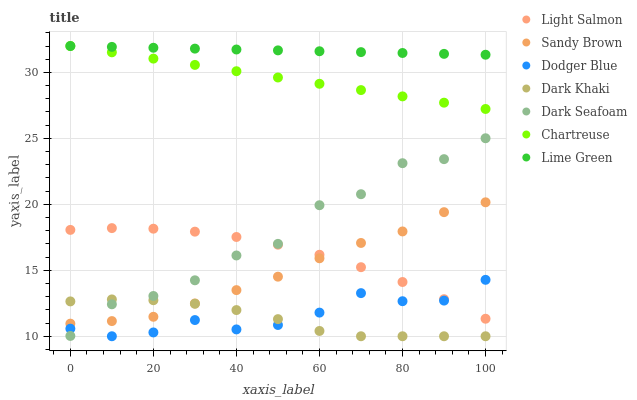Does Dark Khaki have the minimum area under the curve?
Answer yes or no. Yes. Does Lime Green have the maximum area under the curve?
Answer yes or no. Yes. Does Chartreuse have the minimum area under the curve?
Answer yes or no. No. Does Chartreuse have the maximum area under the curve?
Answer yes or no. No. Is Lime Green the smoothest?
Answer yes or no. Yes. Is Dark Seafoam the roughest?
Answer yes or no. Yes. Is Chartreuse the smoothest?
Answer yes or no. No. Is Chartreuse the roughest?
Answer yes or no. No. Does Dark Khaki have the lowest value?
Answer yes or no. Yes. Does Chartreuse have the lowest value?
Answer yes or no. No. Does Chartreuse have the highest value?
Answer yes or no. Yes. Does Dark Khaki have the highest value?
Answer yes or no. No. Is Dodger Blue less than Sandy Brown?
Answer yes or no. Yes. Is Chartreuse greater than Light Salmon?
Answer yes or no. Yes. Does Dark Seafoam intersect Sandy Brown?
Answer yes or no. Yes. Is Dark Seafoam less than Sandy Brown?
Answer yes or no. No. Is Dark Seafoam greater than Sandy Brown?
Answer yes or no. No. Does Dodger Blue intersect Sandy Brown?
Answer yes or no. No. 